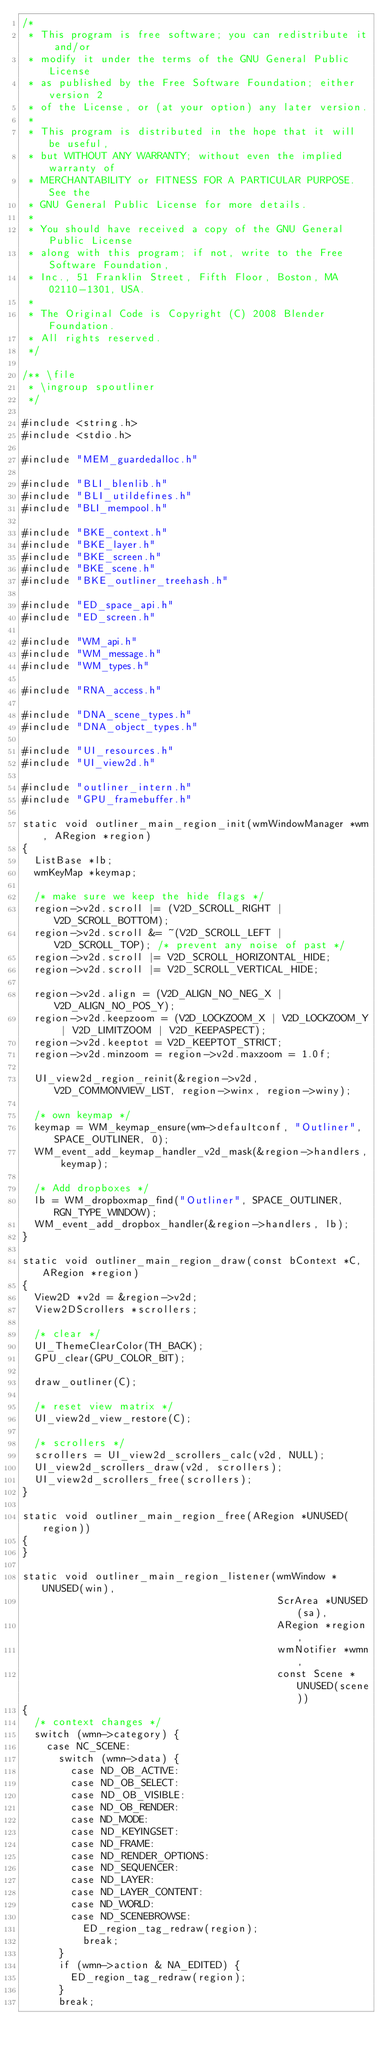Convert code to text. <code><loc_0><loc_0><loc_500><loc_500><_C_>/*
 * This program is free software; you can redistribute it and/or
 * modify it under the terms of the GNU General Public License
 * as published by the Free Software Foundation; either version 2
 * of the License, or (at your option) any later version.
 *
 * This program is distributed in the hope that it will be useful,
 * but WITHOUT ANY WARRANTY; without even the implied warranty of
 * MERCHANTABILITY or FITNESS FOR A PARTICULAR PURPOSE.  See the
 * GNU General Public License for more details.
 *
 * You should have received a copy of the GNU General Public License
 * along with this program; if not, write to the Free Software Foundation,
 * Inc., 51 Franklin Street, Fifth Floor, Boston, MA 02110-1301, USA.
 *
 * The Original Code is Copyright (C) 2008 Blender Foundation.
 * All rights reserved.
 */

/** \file
 * \ingroup spoutliner
 */

#include <string.h>
#include <stdio.h>

#include "MEM_guardedalloc.h"

#include "BLI_blenlib.h"
#include "BLI_utildefines.h"
#include "BLI_mempool.h"

#include "BKE_context.h"
#include "BKE_layer.h"
#include "BKE_screen.h"
#include "BKE_scene.h"
#include "BKE_outliner_treehash.h"

#include "ED_space_api.h"
#include "ED_screen.h"

#include "WM_api.h"
#include "WM_message.h"
#include "WM_types.h"

#include "RNA_access.h"

#include "DNA_scene_types.h"
#include "DNA_object_types.h"

#include "UI_resources.h"
#include "UI_view2d.h"

#include "outliner_intern.h"
#include "GPU_framebuffer.h"

static void outliner_main_region_init(wmWindowManager *wm, ARegion *region)
{
  ListBase *lb;
  wmKeyMap *keymap;

  /* make sure we keep the hide flags */
  region->v2d.scroll |= (V2D_SCROLL_RIGHT | V2D_SCROLL_BOTTOM);
  region->v2d.scroll &= ~(V2D_SCROLL_LEFT | V2D_SCROLL_TOP); /* prevent any noise of past */
  region->v2d.scroll |= V2D_SCROLL_HORIZONTAL_HIDE;
  region->v2d.scroll |= V2D_SCROLL_VERTICAL_HIDE;

  region->v2d.align = (V2D_ALIGN_NO_NEG_X | V2D_ALIGN_NO_POS_Y);
  region->v2d.keepzoom = (V2D_LOCKZOOM_X | V2D_LOCKZOOM_Y | V2D_LIMITZOOM | V2D_KEEPASPECT);
  region->v2d.keeptot = V2D_KEEPTOT_STRICT;
  region->v2d.minzoom = region->v2d.maxzoom = 1.0f;

  UI_view2d_region_reinit(&region->v2d, V2D_COMMONVIEW_LIST, region->winx, region->winy);

  /* own keymap */
  keymap = WM_keymap_ensure(wm->defaultconf, "Outliner", SPACE_OUTLINER, 0);
  WM_event_add_keymap_handler_v2d_mask(&region->handlers, keymap);

  /* Add dropboxes */
  lb = WM_dropboxmap_find("Outliner", SPACE_OUTLINER, RGN_TYPE_WINDOW);
  WM_event_add_dropbox_handler(&region->handlers, lb);
}

static void outliner_main_region_draw(const bContext *C, ARegion *region)
{
  View2D *v2d = &region->v2d;
  View2DScrollers *scrollers;

  /* clear */
  UI_ThemeClearColor(TH_BACK);
  GPU_clear(GPU_COLOR_BIT);

  draw_outliner(C);

  /* reset view matrix */
  UI_view2d_view_restore(C);

  /* scrollers */
  scrollers = UI_view2d_scrollers_calc(v2d, NULL);
  UI_view2d_scrollers_draw(v2d, scrollers);
  UI_view2d_scrollers_free(scrollers);
}

static void outliner_main_region_free(ARegion *UNUSED(region))
{
}

static void outliner_main_region_listener(wmWindow *UNUSED(win),
                                          ScrArea *UNUSED(sa),
                                          ARegion *region,
                                          wmNotifier *wmn,
                                          const Scene *UNUSED(scene))
{
  /* context changes */
  switch (wmn->category) {
    case NC_SCENE:
      switch (wmn->data) {
        case ND_OB_ACTIVE:
        case ND_OB_SELECT:
        case ND_OB_VISIBLE:
        case ND_OB_RENDER:
        case ND_MODE:
        case ND_KEYINGSET:
        case ND_FRAME:
        case ND_RENDER_OPTIONS:
        case ND_SEQUENCER:
        case ND_LAYER:
        case ND_LAYER_CONTENT:
        case ND_WORLD:
        case ND_SCENEBROWSE:
          ED_region_tag_redraw(region);
          break;
      }
      if (wmn->action & NA_EDITED) {
        ED_region_tag_redraw(region);
      }
      break;</code> 